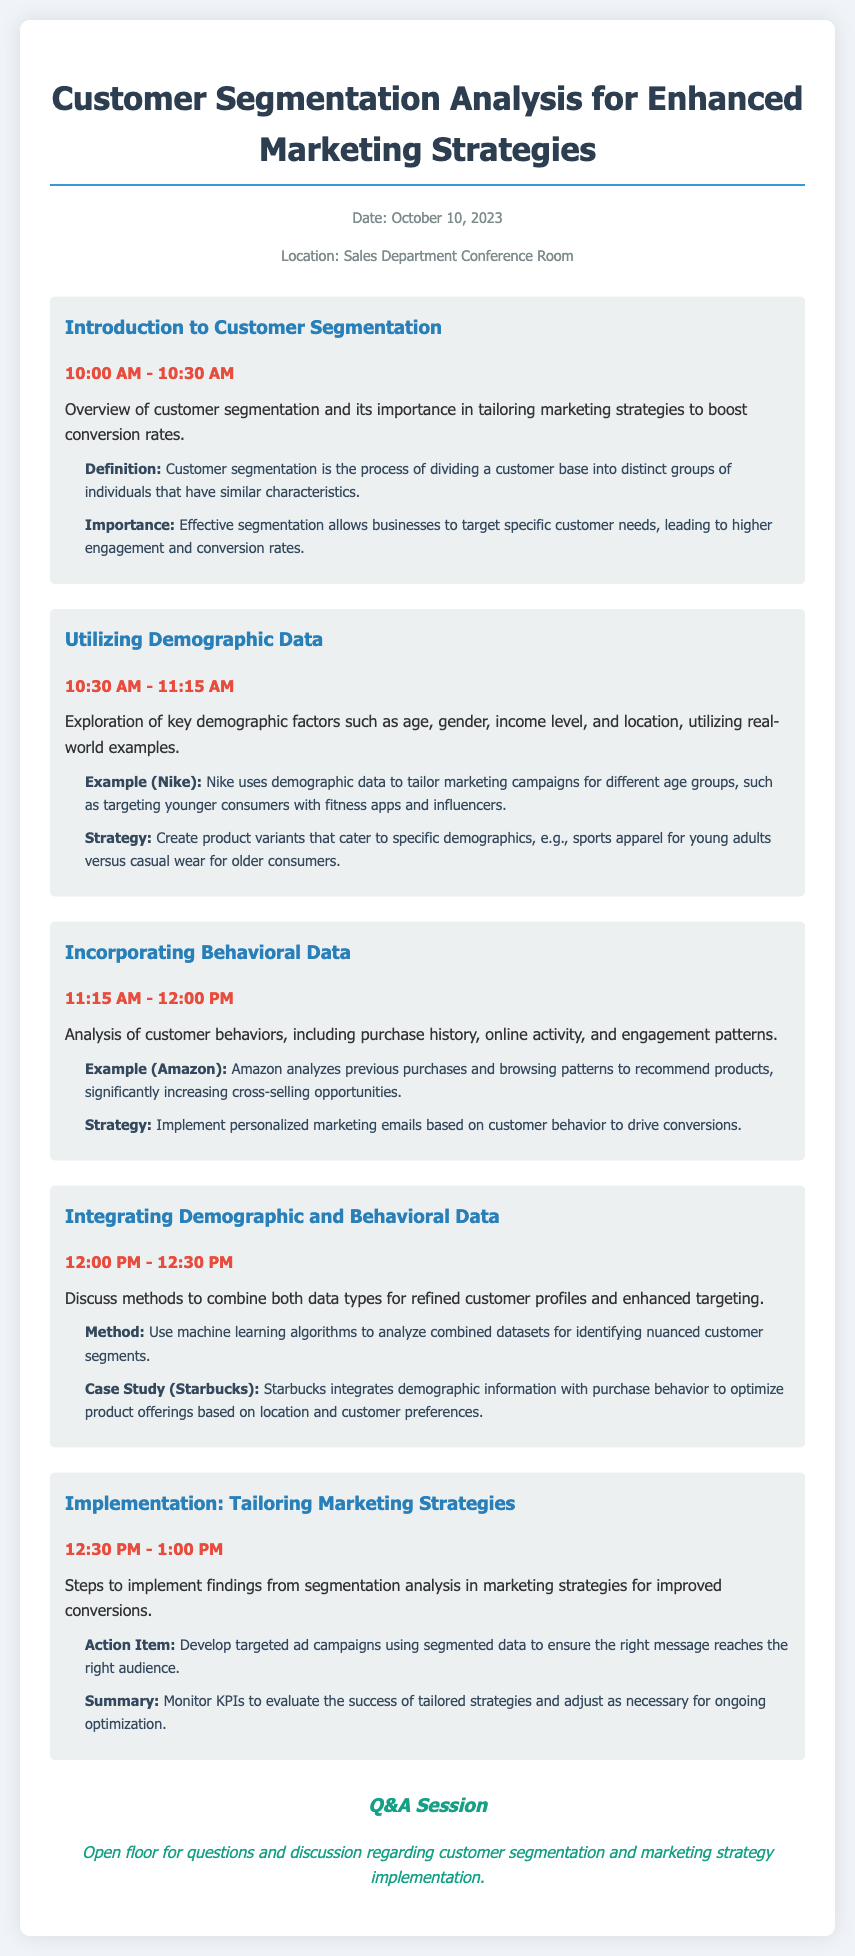what is the date of the agenda? The date mentioned in the document is October 10, 2023.
Answer: October 10, 2023 where is the meeting location? The document specifies the location as the Sales Department Conference Room.
Answer: Sales Department Conference Room what time does the introduction to customer segmentation start? The introduction to customer segmentation begins at 10:00 AM.
Answer: 10:00 AM what example is given for demographic data usage? The document provides Nike as an example of using demographic data to tailor marketing campaigns.
Answer: Nike what is the main method discussed for integrating data? The document mentions using machine learning algorithms as the method to combine data types.
Answer: Machine learning algorithms how long is the session on implementing marketing strategies? The session on tailoring marketing strategies is scheduled for 30 minutes.
Answer: 30 minutes what is one action item from the implementation section? The document lists developing targeted ad campaigns using segmented data as an action item.
Answer: Develop targeted ad campaigns what case study is presented for integrating data? The document includes Starbucks as a case study for integrating demographic and behavioral data.
Answer: Starbucks how is the Q&A session labeled in the document? The Q&A session is labeled simply as "Q&A Session."
Answer: Q&A Session 